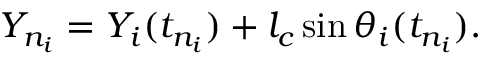Convert formula to latex. <formula><loc_0><loc_0><loc_500><loc_500>Y _ { n _ { i } } = Y _ { i } ( t _ { n _ { i } } ) + l _ { c } \sin \theta _ { i } ( t _ { n _ { i } } ) .</formula> 